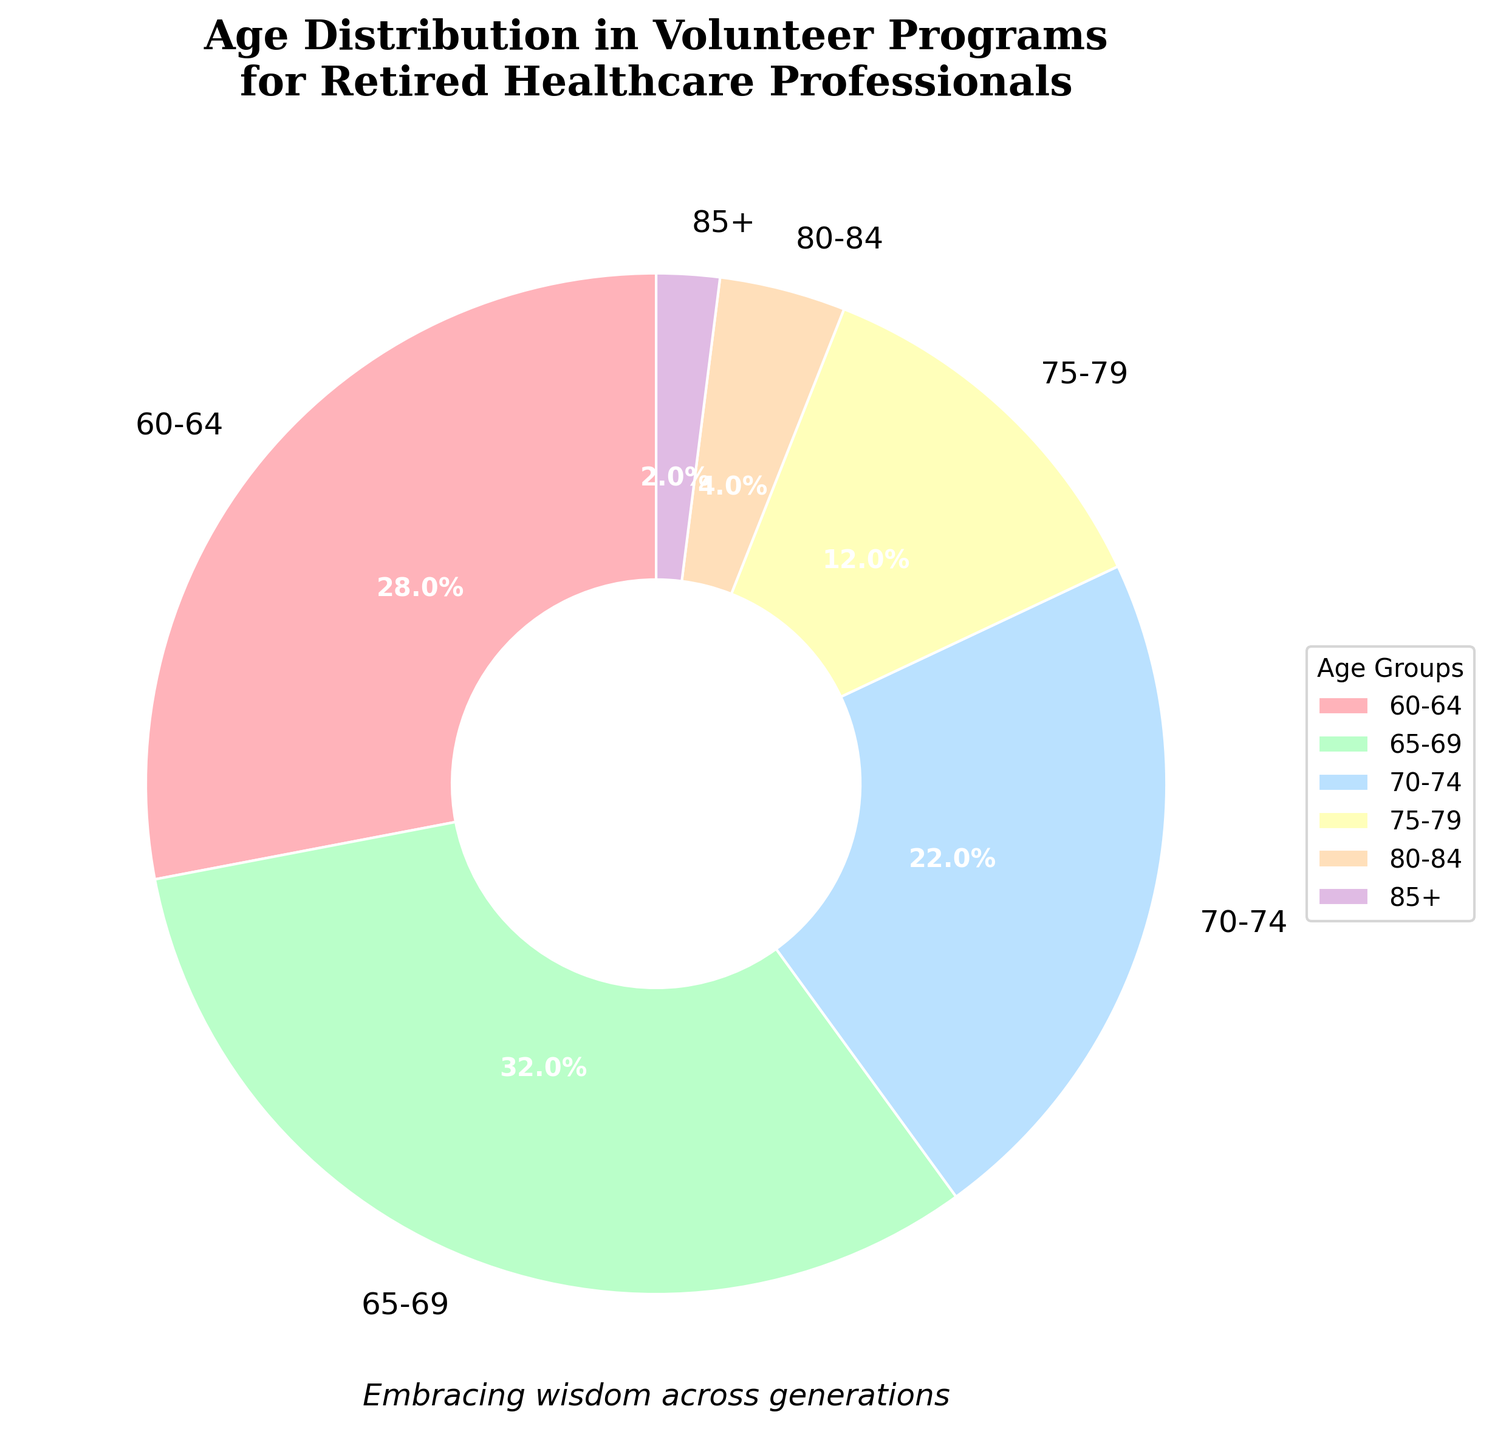1. What age group has the highest percentage in the volunteer programs? The pie chart shows the distribution of age groups, and the segment covering the 65-69 age group appears the largest, indicating the highest percentage.
Answer: 65-69 2. How much more percentage does the age group 60-64 have compared to the age group 70-74? From the pie chart, the 60-64 age group has 28%, and the 70-74 age group has 22%. The difference can be calculated as 28% - 22% = 6%.
Answer: 6% 3. What is the combined percentage of the age groups 75-79 and 80-84? The percentage of the age group 75-79 is 12%, and the percentage of the age group 80-84 is 4%. Adding these gives 12% + 4% = 16%.
Answer: 16% 4. Which age group has a smaller percentage, 80-84 or 85+? By comparing the visual segments, the 85+ age group has a smaller percentage of 2% compared to the 4% of the 80-84 age group.
Answer: 85+ 5. What proportion of the volunteers are aged 70 or older? Combine the percentages of the age groups 70-74 (22%), 75-79 (12%), 80-84 (4%), and 85+ (2%). The total is 22% + 12% + 4% + 2% = 40%.
Answer: 40% 6. If you look at the colors, which color represents the age group 75-79? The pie chart segments display different colors for each age group. The color representing the 75-79 age group can be identified visually as it matches the specific color listed in its legend.
Answer: Orange (or appropriate color based on the provided palette) 7. What is the difference in percentage between the largest and smallest represented age groups? The largest represented age group 65-69 is 32%. The smallest represented age group 85+ is 2%. The difference is 32% - 2% = 30%.
Answer: 30% 8. Which age group has a percentage closest to a quarter of the total distribution? A quarter of the total distribution is 25%. The age group 60-64 closely aligns with this, having a percentage of 28%.
Answer: 60-64 9. How does the percentage of the age group 60-64 compare to the combined percentage of the age groups 80-84 and 85+? The age group 60-64 has 28%, while the combined percentage of 80-84 (4%) and 85+ (2%) is 4% + 2% = 6%. 28% is significantly higher than 6%.
Answer: Significantly higher 10. What is the average percentage of the age groups under 70? The percentages for the age groups under 70 (60-64 and 65-69) are 28% and 32%. The average is (28 + 32) / 2 = 30%.
Answer: 30% 